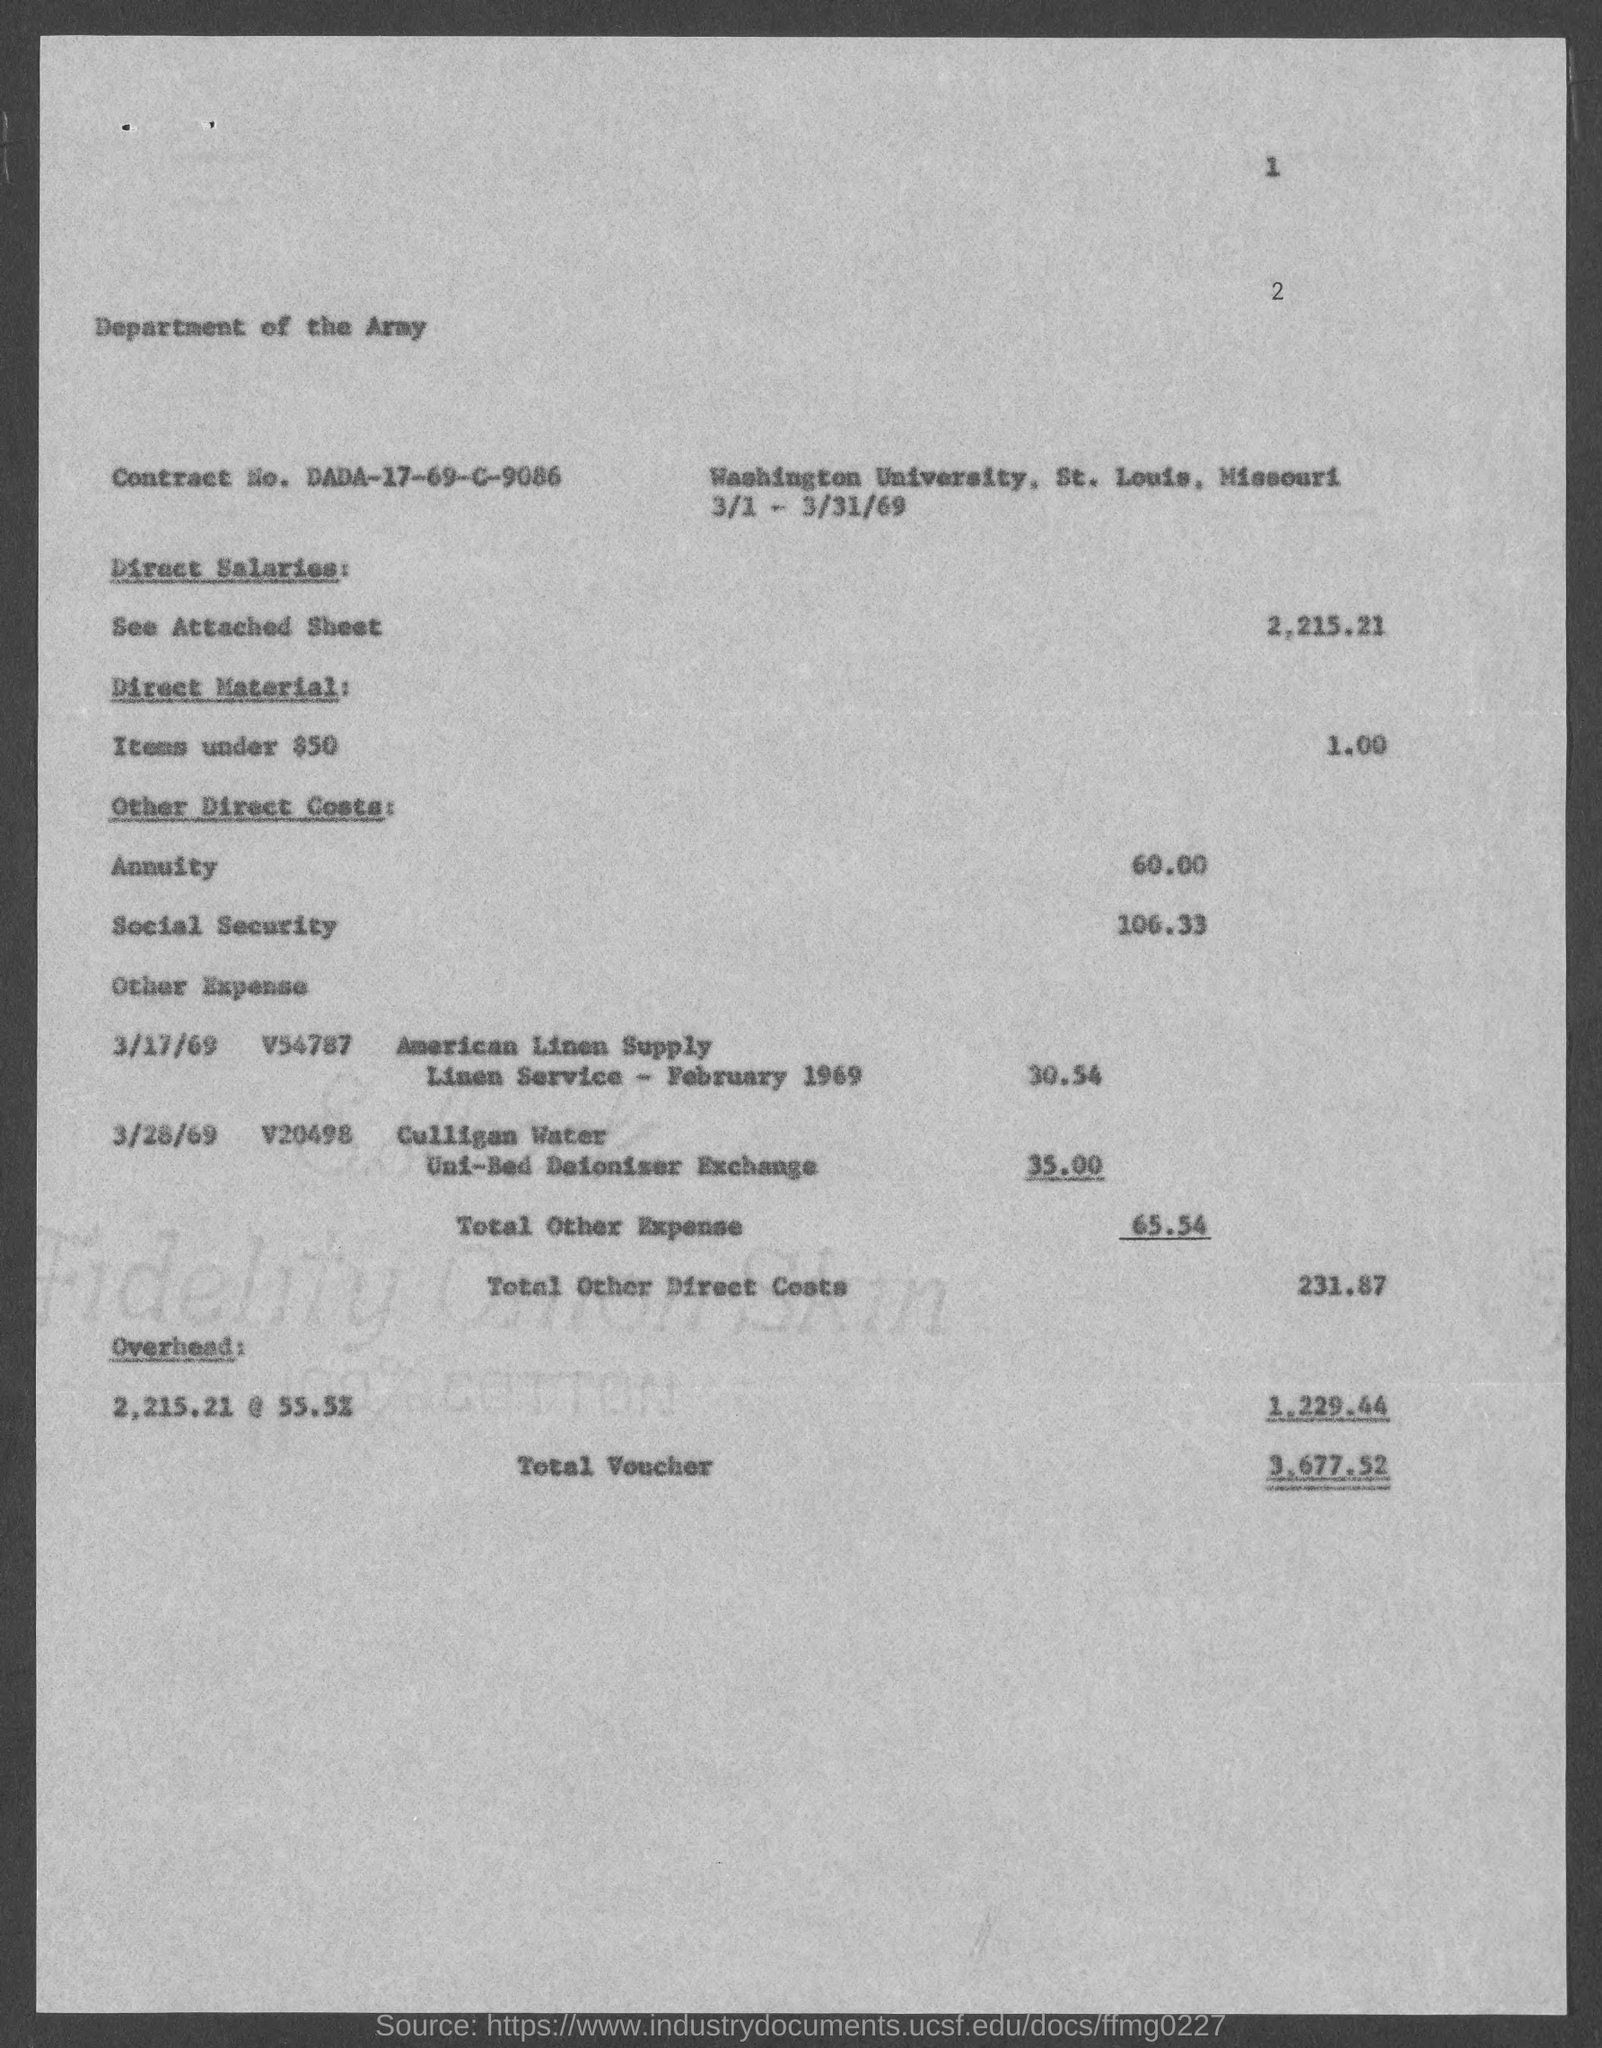Point out several critical features in this image. The Contract No. is DADA-17-69-C-9086. The total voucher amount is 3,677.52. 